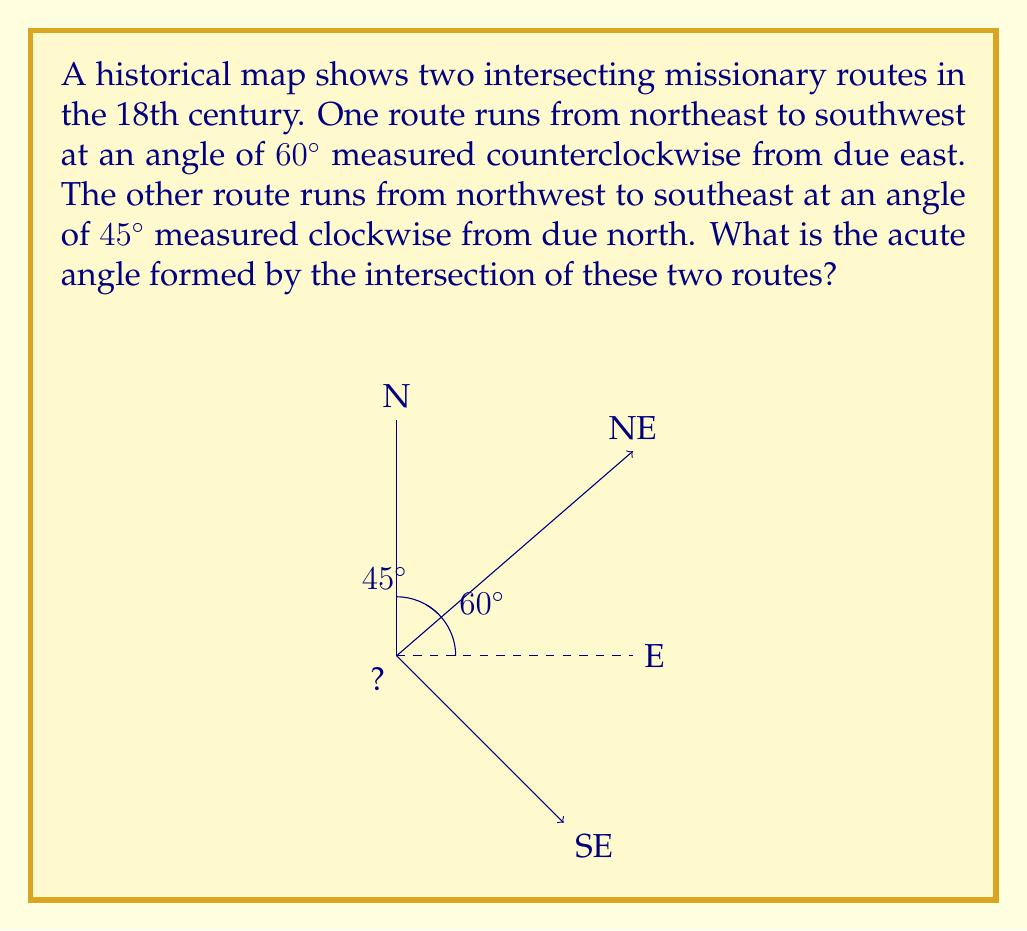Give your solution to this math problem. To solve this problem, we need to follow these steps:

1) First, let's visualize the situation. We have two angles measured from different reference lines:
   - Route 1: $60^\circ$ counterclockwise from east
   - Route 2: $45^\circ$ clockwise from north

2) To find the angle between these routes, we need to express both angles in terms of the same reference line. Let's use the east-west line as our reference.

3) Route 1 is already measured from east: $60^\circ$ counterclockwise.

4) For Route 2, we need to convert its angle:
   - From north to east is $90^\circ$
   - The route is $45^\circ$ clockwise from north
   - So from east, it's $90^\circ - 45^\circ = 45^\circ$ counterclockwise

5) Now we have both angles measured counterclockwise from east:
   - Route 1: $60^\circ$
   - Route 2: $45^\circ$

6) The angle between the routes is the absolute difference between these angles:

   $|60^\circ - 45^\circ| = 15^\circ$

Therefore, the acute angle formed by the intersection of these two missionary routes is $15^\circ$.
Answer: $15^\circ$ 